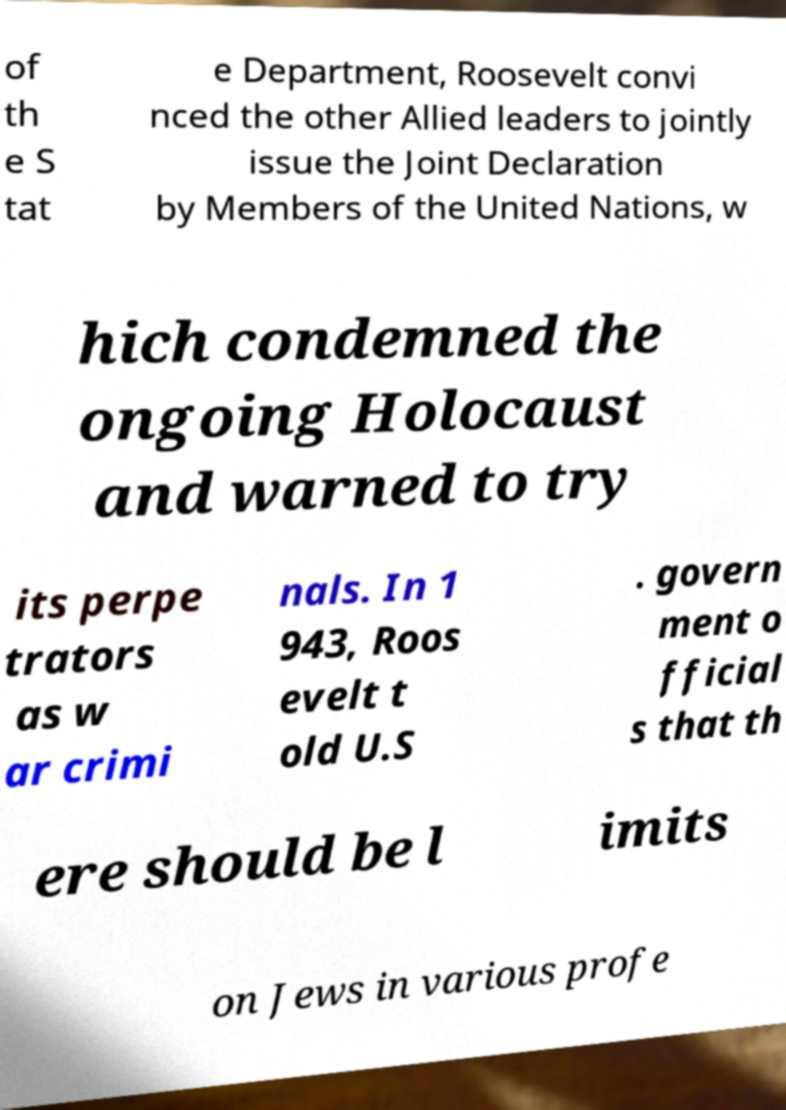I need the written content from this picture converted into text. Can you do that? of th e S tat e Department, Roosevelt convi nced the other Allied leaders to jointly issue the Joint Declaration by Members of the United Nations, w hich condemned the ongoing Holocaust and warned to try its perpe trators as w ar crimi nals. In 1 943, Roos evelt t old U.S . govern ment o fficial s that th ere should be l imits on Jews in various profe 